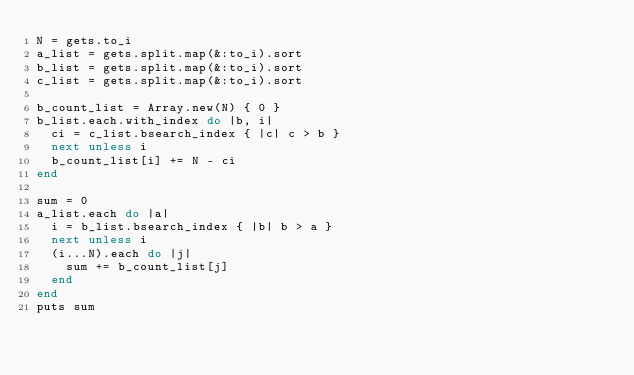<code> <loc_0><loc_0><loc_500><loc_500><_Ruby_>N = gets.to_i
a_list = gets.split.map(&:to_i).sort
b_list = gets.split.map(&:to_i).sort
c_list = gets.split.map(&:to_i).sort

b_count_list = Array.new(N) { 0 }
b_list.each.with_index do |b, i|
  ci = c_list.bsearch_index { |c| c > b }
  next unless i
  b_count_list[i] += N - ci
end

sum = 0
a_list.each do |a|
  i = b_list.bsearch_index { |b| b > a }
  next unless i
  (i...N).each do |j|
    sum += b_count_list[j]
  end
end
puts sum
</code> 